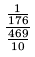Convert formula to latex. <formula><loc_0><loc_0><loc_500><loc_500>\frac { \frac { 1 } { 1 7 6 } } { \frac { 4 6 9 } { 1 0 } }</formula> 